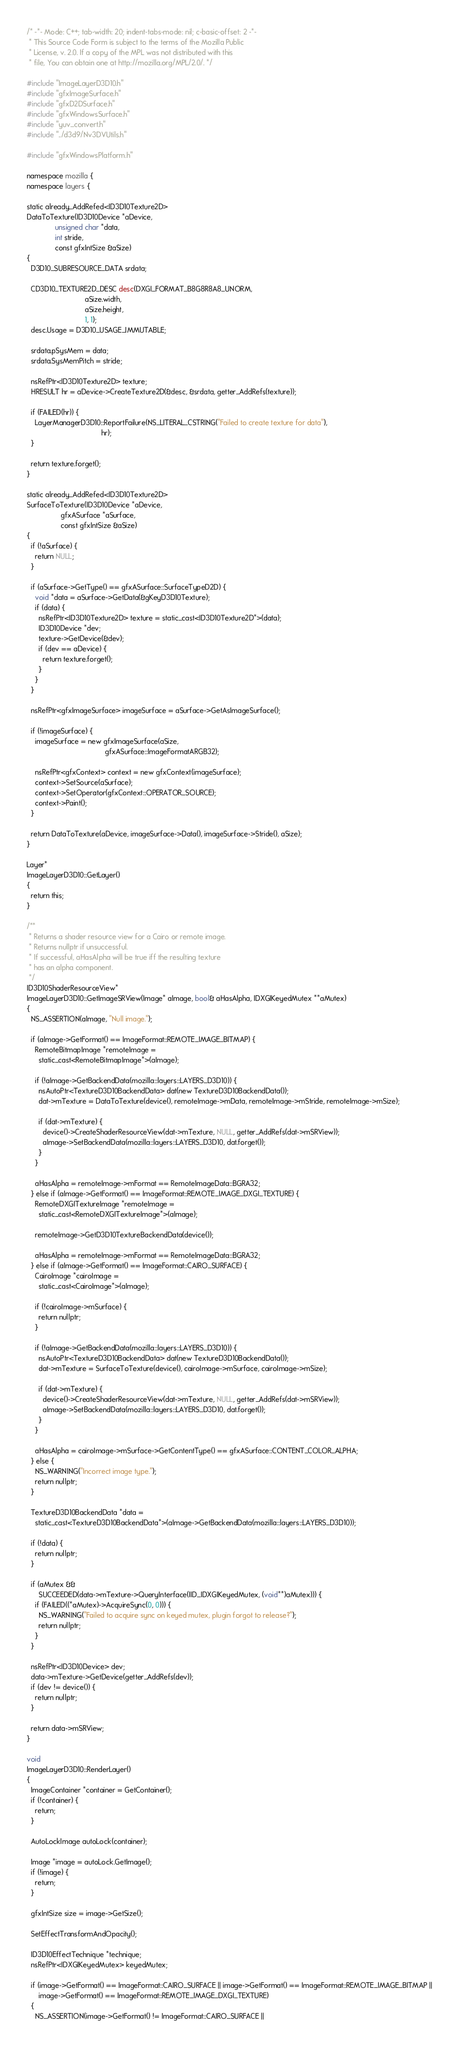<code> <loc_0><loc_0><loc_500><loc_500><_C++_>/* -*- Mode: C++; tab-width: 20; indent-tabs-mode: nil; c-basic-offset: 2 -*-
 * This Source Code Form is subject to the terms of the Mozilla Public
 * License, v. 2.0. If a copy of the MPL was not distributed with this
 * file, You can obtain one at http://mozilla.org/MPL/2.0/. */

#include "ImageLayerD3D10.h"
#include "gfxImageSurface.h"
#include "gfxD2DSurface.h"
#include "gfxWindowsSurface.h"
#include "yuv_convert.h"
#include "../d3d9/Nv3DVUtils.h"

#include "gfxWindowsPlatform.h"

namespace mozilla {
namespace layers {

static already_AddRefed<ID3D10Texture2D>
DataToTexture(ID3D10Device *aDevice,
              unsigned char *data,
              int stride,
              const gfxIntSize &aSize)
{
  D3D10_SUBRESOURCE_DATA srdata;

  CD3D10_TEXTURE2D_DESC desc(DXGI_FORMAT_B8G8R8A8_UNORM,
                             aSize.width,
                             aSize.height,
                             1, 1);
  desc.Usage = D3D10_USAGE_IMMUTABLE;

  srdata.pSysMem = data;
  srdata.SysMemPitch = stride;

  nsRefPtr<ID3D10Texture2D> texture;
  HRESULT hr = aDevice->CreateTexture2D(&desc, &srdata, getter_AddRefs(texture));

  if (FAILED(hr)) {
    LayerManagerD3D10::ReportFailure(NS_LITERAL_CSTRING("Failed to create texture for data"),
                                     hr);
  }

  return texture.forget();
}

static already_AddRefed<ID3D10Texture2D>
SurfaceToTexture(ID3D10Device *aDevice,
                 gfxASurface *aSurface,
                 const gfxIntSize &aSize)
{
  if (!aSurface) {
    return NULL;
  }

  if (aSurface->GetType() == gfxASurface::SurfaceTypeD2D) {
    void *data = aSurface->GetData(&gKeyD3D10Texture);
    if (data) {
      nsRefPtr<ID3D10Texture2D> texture = static_cast<ID3D10Texture2D*>(data);
      ID3D10Device *dev;
      texture->GetDevice(&dev);
      if (dev == aDevice) {
        return texture.forget();
      }
    }
  }

  nsRefPtr<gfxImageSurface> imageSurface = aSurface->GetAsImageSurface();

  if (!imageSurface) {
    imageSurface = new gfxImageSurface(aSize,
                                       gfxASurface::ImageFormatARGB32);

    nsRefPtr<gfxContext> context = new gfxContext(imageSurface);
    context->SetSource(aSurface);
    context->SetOperator(gfxContext::OPERATOR_SOURCE);
    context->Paint();
  }

  return DataToTexture(aDevice, imageSurface->Data(), imageSurface->Stride(), aSize);
}

Layer*
ImageLayerD3D10::GetLayer()
{
  return this;
}

/**
 * Returns a shader resource view for a Cairo or remote image.
 * Returns nullptr if unsuccessful.
 * If successful, aHasAlpha will be true iff the resulting texture 
 * has an alpha component.
 */
ID3D10ShaderResourceView*
ImageLayerD3D10::GetImageSRView(Image* aImage, bool& aHasAlpha, IDXGIKeyedMutex **aMutex)
{
  NS_ASSERTION(aImage, "Null image.");

  if (aImage->GetFormat() == ImageFormat::REMOTE_IMAGE_BITMAP) {
    RemoteBitmapImage *remoteImage =
      static_cast<RemoteBitmapImage*>(aImage);

    if (!aImage->GetBackendData(mozilla::layers::LAYERS_D3D10)) {
      nsAutoPtr<TextureD3D10BackendData> dat(new TextureD3D10BackendData());
      dat->mTexture = DataToTexture(device(), remoteImage->mData, remoteImage->mStride, remoteImage->mSize);

      if (dat->mTexture) {
        device()->CreateShaderResourceView(dat->mTexture, NULL, getter_AddRefs(dat->mSRView));
        aImage->SetBackendData(mozilla::layers::LAYERS_D3D10, dat.forget());
      }
    }

    aHasAlpha = remoteImage->mFormat == RemoteImageData::BGRA32;
  } else if (aImage->GetFormat() == ImageFormat::REMOTE_IMAGE_DXGI_TEXTURE) {
    RemoteDXGITextureImage *remoteImage =
      static_cast<RemoteDXGITextureImage*>(aImage);

    remoteImage->GetD3D10TextureBackendData(device());

    aHasAlpha = remoteImage->mFormat == RemoteImageData::BGRA32;
  } else if (aImage->GetFormat() == ImageFormat::CAIRO_SURFACE) {
    CairoImage *cairoImage =
      static_cast<CairoImage*>(aImage);

    if (!cairoImage->mSurface) {
      return nullptr;
    }

    if (!aImage->GetBackendData(mozilla::layers::LAYERS_D3D10)) {
      nsAutoPtr<TextureD3D10BackendData> dat(new TextureD3D10BackendData());
      dat->mTexture = SurfaceToTexture(device(), cairoImage->mSurface, cairoImage->mSize);

      if (dat->mTexture) {
        device()->CreateShaderResourceView(dat->mTexture, NULL, getter_AddRefs(dat->mSRView));
        aImage->SetBackendData(mozilla::layers::LAYERS_D3D10, dat.forget());
      }
    }

    aHasAlpha = cairoImage->mSurface->GetContentType() == gfxASurface::CONTENT_COLOR_ALPHA;
  } else {
    NS_WARNING("Incorrect image type.");
    return nullptr;
  }

  TextureD3D10BackendData *data =
    static_cast<TextureD3D10BackendData*>(aImage->GetBackendData(mozilla::layers::LAYERS_D3D10));

  if (!data) {
    return nullptr;
  }

  if (aMutex &&
      SUCCEEDED(data->mTexture->QueryInterface(IID_IDXGIKeyedMutex, (void**)aMutex))) {
    if (FAILED((*aMutex)->AcquireSync(0, 0))) {
      NS_WARNING("Failed to acquire sync on keyed mutex, plugin forgot to release?");
      return nullptr;
    }
  }

  nsRefPtr<ID3D10Device> dev;
  data->mTexture->GetDevice(getter_AddRefs(dev));
  if (dev != device()) {
    return nullptr;
  }

  return data->mSRView;
}

void
ImageLayerD3D10::RenderLayer()
{
  ImageContainer *container = GetContainer();
  if (!container) {
    return;
  }

  AutoLockImage autoLock(container);

  Image *image = autoLock.GetImage();
  if (!image) {
    return;
  }

  gfxIntSize size = image->GetSize();

  SetEffectTransformAndOpacity();

  ID3D10EffectTechnique *technique;
  nsRefPtr<IDXGIKeyedMutex> keyedMutex;

  if (image->GetFormat() == ImageFormat::CAIRO_SURFACE || image->GetFormat() == ImageFormat::REMOTE_IMAGE_BITMAP ||
      image->GetFormat() == ImageFormat::REMOTE_IMAGE_DXGI_TEXTURE)
  {
    NS_ASSERTION(image->GetFormat() != ImageFormat::CAIRO_SURFACE ||</code> 